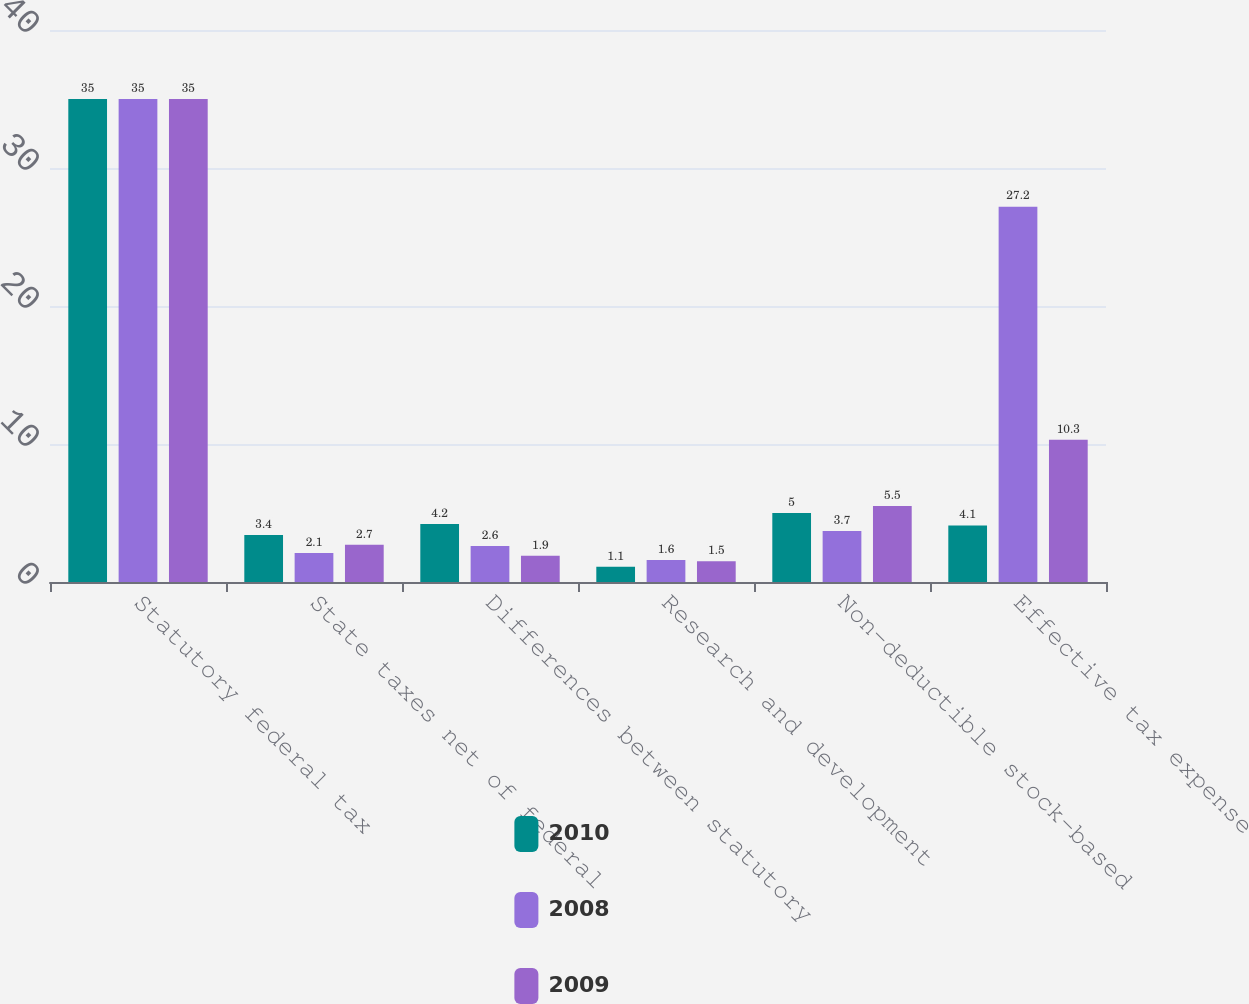<chart> <loc_0><loc_0><loc_500><loc_500><stacked_bar_chart><ecel><fcel>Statutory federal tax<fcel>State taxes net of federal<fcel>Differences between statutory<fcel>Research and development<fcel>Non-deductible stock-based<fcel>Effective tax expense<nl><fcel>2010<fcel>35<fcel>3.4<fcel>4.2<fcel>1.1<fcel>5<fcel>4.1<nl><fcel>2008<fcel>35<fcel>2.1<fcel>2.6<fcel>1.6<fcel>3.7<fcel>27.2<nl><fcel>2009<fcel>35<fcel>2.7<fcel>1.9<fcel>1.5<fcel>5.5<fcel>10.3<nl></chart> 